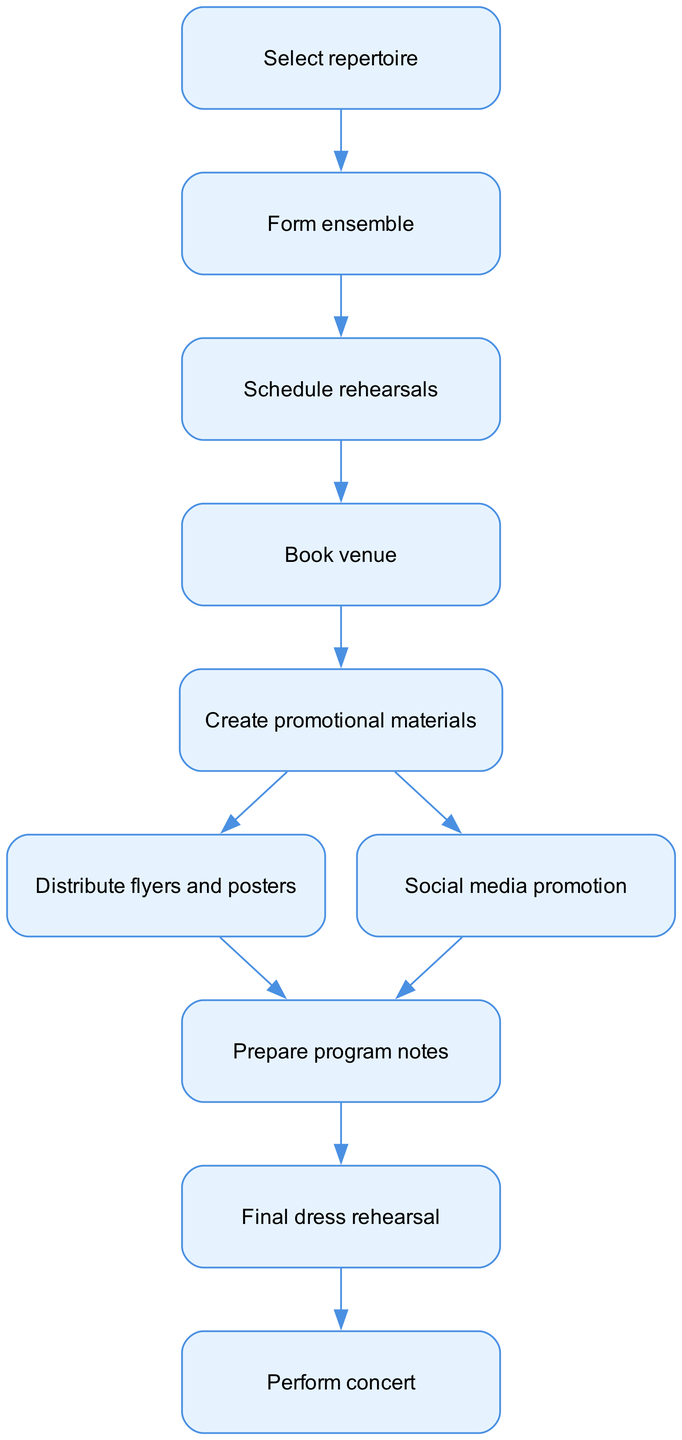What is the first step in the workflow? The first node in the diagram is labeled "Select repertoire," indicating that this is the initial step of the process.
Answer: Select repertoire How many nodes are in the diagram? The diagram consists of ten distinct nodes, each representing a different step in the workflow.
Answer: 10 What follows after "Book venue"? The flow from "Book venue" leads directly to "Create promotional materials," indicating that this is the next action to be taken after booking the venue.
Answer: Create promotional materials Which two promotional methods are listed in the workflow? The diagram includes two promotional methods: "Distribute flyers and posters" and "Social media promotion," both connected to the "Create promotional materials" node.
Answer: Distribute flyers and posters, Social media promotion What is the final step before the concert? The last action before performing the concert is the "Final dress rehearsal," which is the penultimate node in the workflow leading up to the event.
Answer: Final dress rehearsal At which point in the workflow do you prepare program notes? Program notes preparation occurs after either "Distribute flyers and posters" or "Social media promotion," as both these nodes direct to "Prepare program notes."
Answer: Prepare program notes How many promotional actions are there in total? There are three promotional actions: "Distribute flyers and posters," "Social media promotion," and the preparation of "program notes," all associated with promoting the concert.
Answer: 3 Which node indicates the formation of the ensemble? The formation of the ensemble is indicated by the node labeled "Form ensemble," which follows directly after selecting the repertoire.
Answer: Form ensemble 